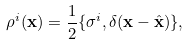<formula> <loc_0><loc_0><loc_500><loc_500>\rho ^ { i } ( \mathbf x ) = \frac { 1 } { 2 } \{ \sigma ^ { i } , \delta ( \mathbf x - \hat { \mathbf x } ) \} ,</formula> 